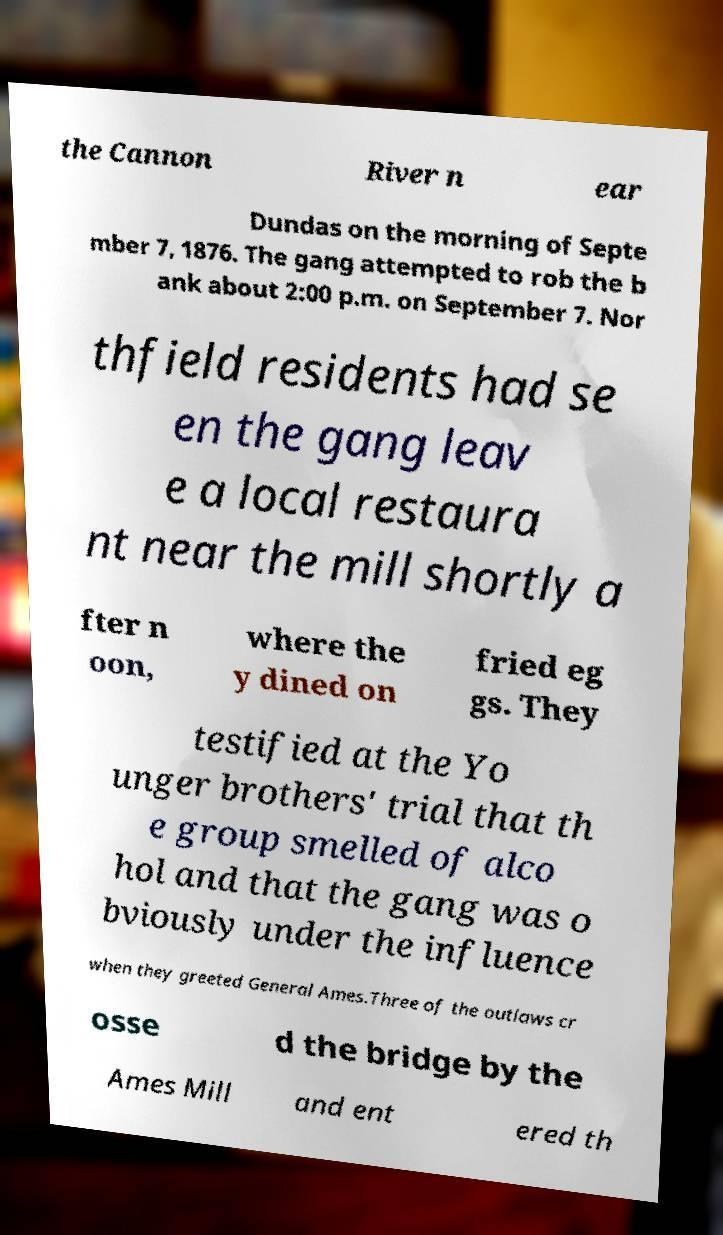Could you extract and type out the text from this image? the Cannon River n ear Dundas on the morning of Septe mber 7, 1876. The gang attempted to rob the b ank about 2:00 p.m. on September 7. Nor thfield residents had se en the gang leav e a local restaura nt near the mill shortly a fter n oon, where the y dined on fried eg gs. They testified at the Yo unger brothers' trial that th e group smelled of alco hol and that the gang was o bviously under the influence when they greeted General Ames.Three of the outlaws cr osse d the bridge by the Ames Mill and ent ered th 